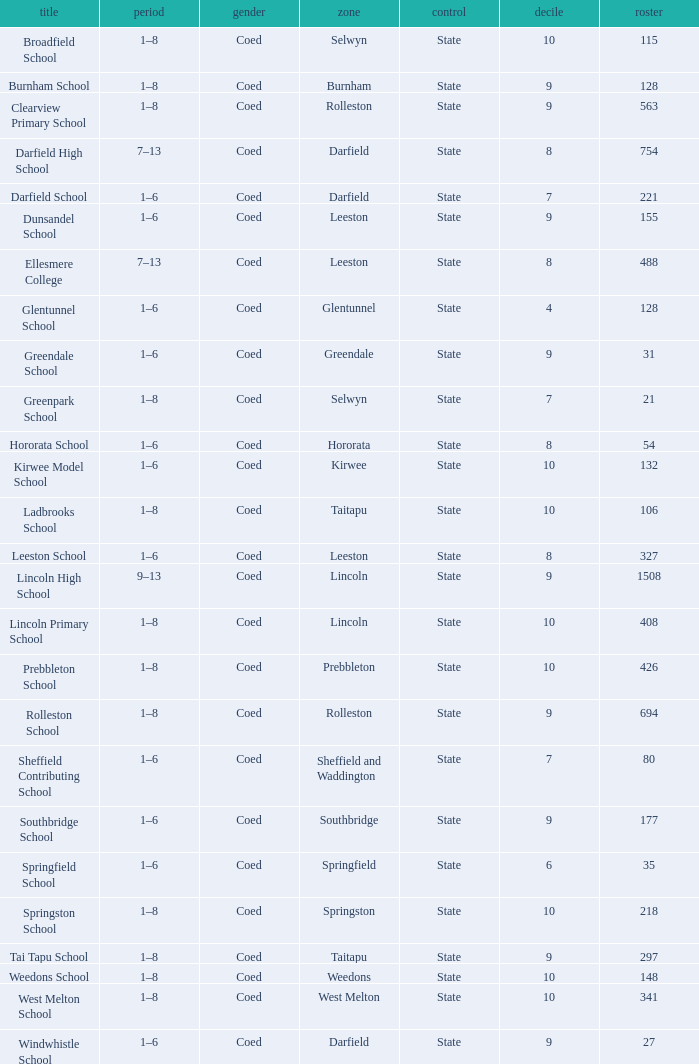How many deciles have Years of 9–13? 1.0. 